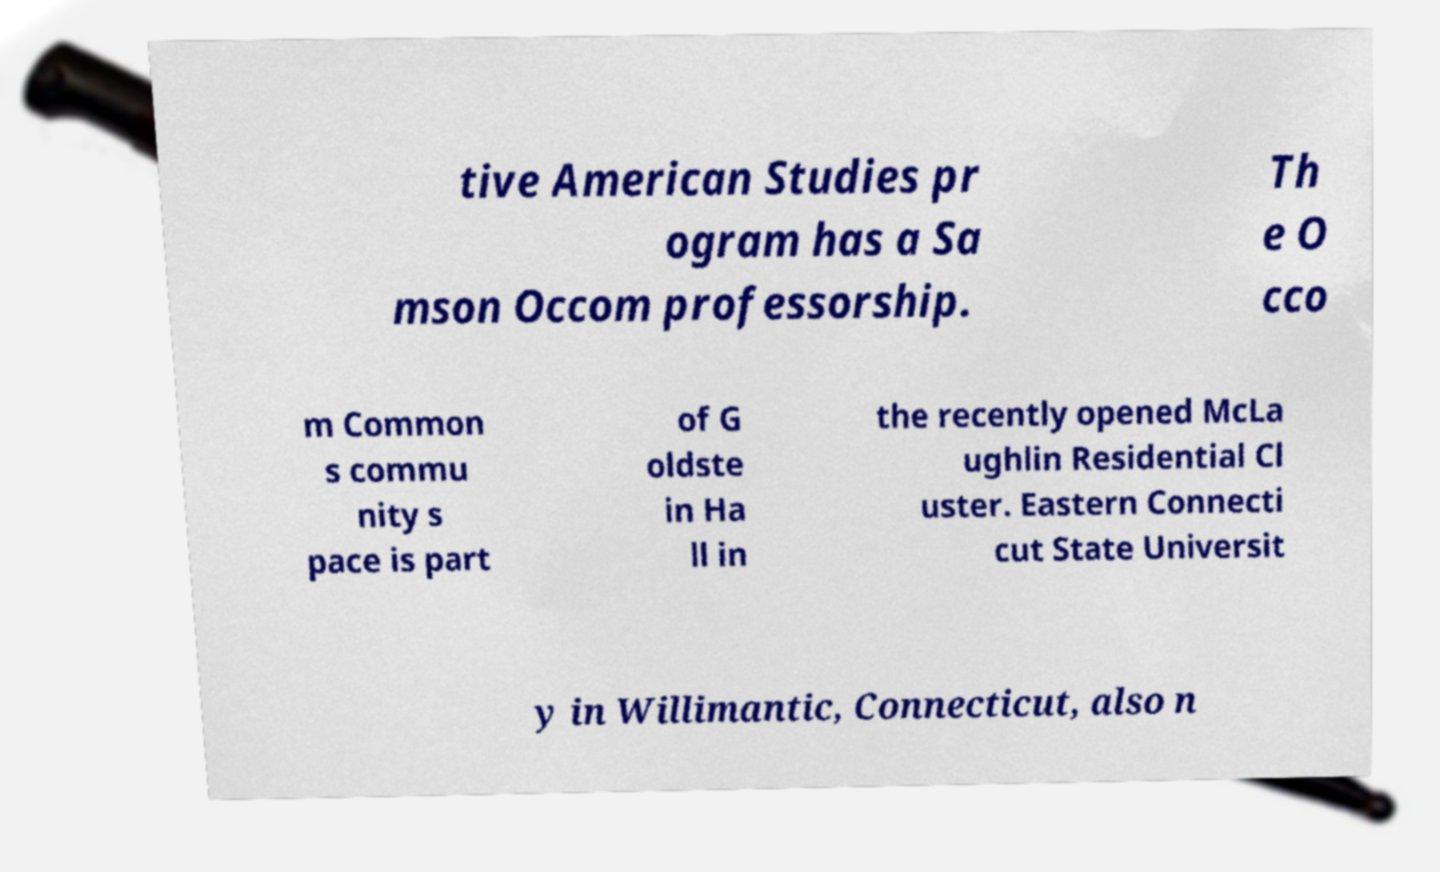Could you assist in decoding the text presented in this image and type it out clearly? tive American Studies pr ogram has a Sa mson Occom professorship. Th e O cco m Common s commu nity s pace is part of G oldste in Ha ll in the recently opened McLa ughlin Residential Cl uster. Eastern Connecti cut State Universit y in Willimantic, Connecticut, also n 